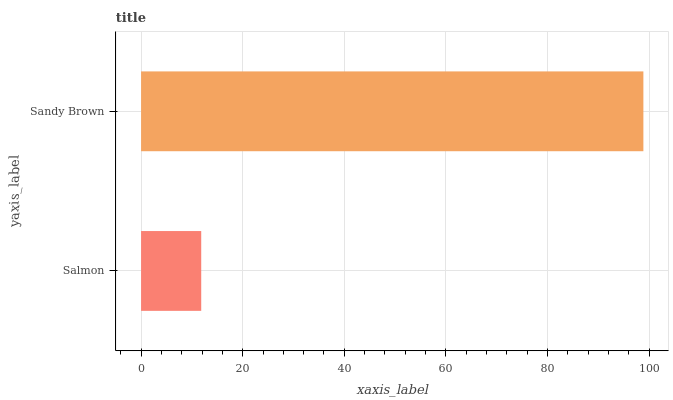Is Salmon the minimum?
Answer yes or no. Yes. Is Sandy Brown the maximum?
Answer yes or no. Yes. Is Sandy Brown the minimum?
Answer yes or no. No. Is Sandy Brown greater than Salmon?
Answer yes or no. Yes. Is Salmon less than Sandy Brown?
Answer yes or no. Yes. Is Salmon greater than Sandy Brown?
Answer yes or no. No. Is Sandy Brown less than Salmon?
Answer yes or no. No. Is Sandy Brown the high median?
Answer yes or no. Yes. Is Salmon the low median?
Answer yes or no. Yes. Is Salmon the high median?
Answer yes or no. No. Is Sandy Brown the low median?
Answer yes or no. No. 